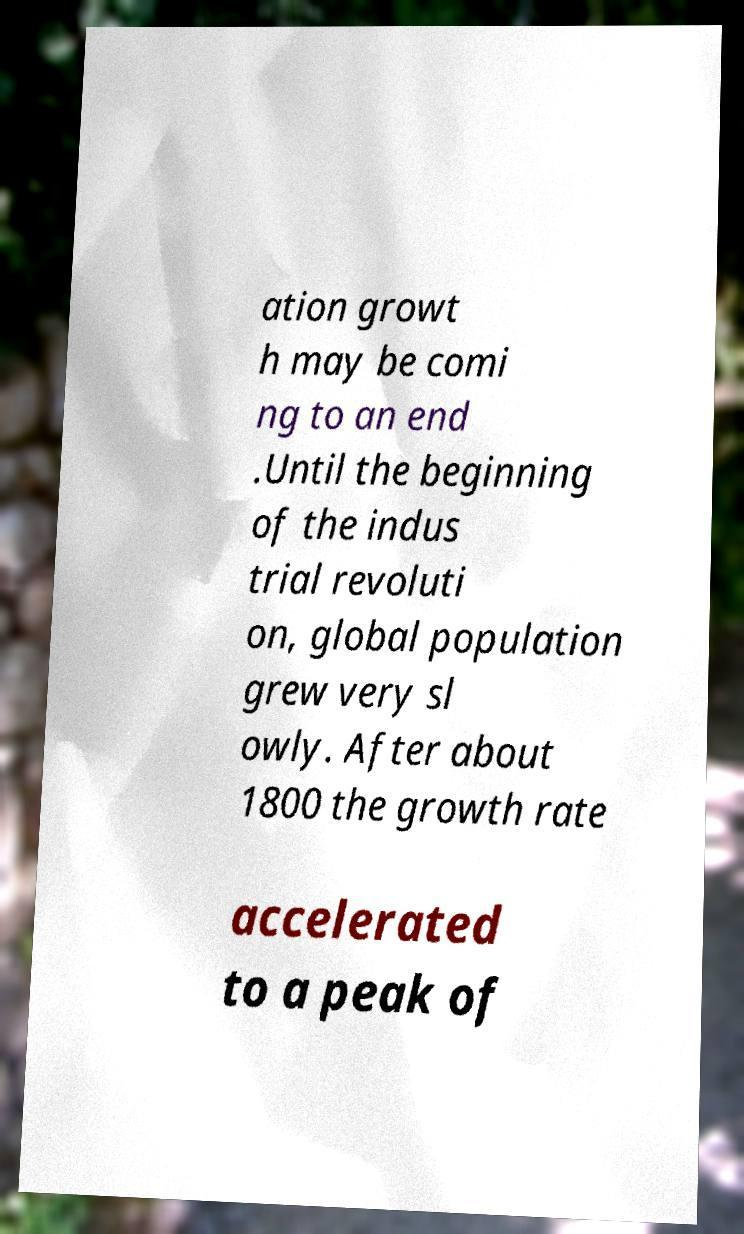Can you read and provide the text displayed in the image?This photo seems to have some interesting text. Can you extract and type it out for me? ation growt h may be comi ng to an end .Until the beginning of the indus trial revoluti on, global population grew very sl owly. After about 1800 the growth rate accelerated to a peak of 